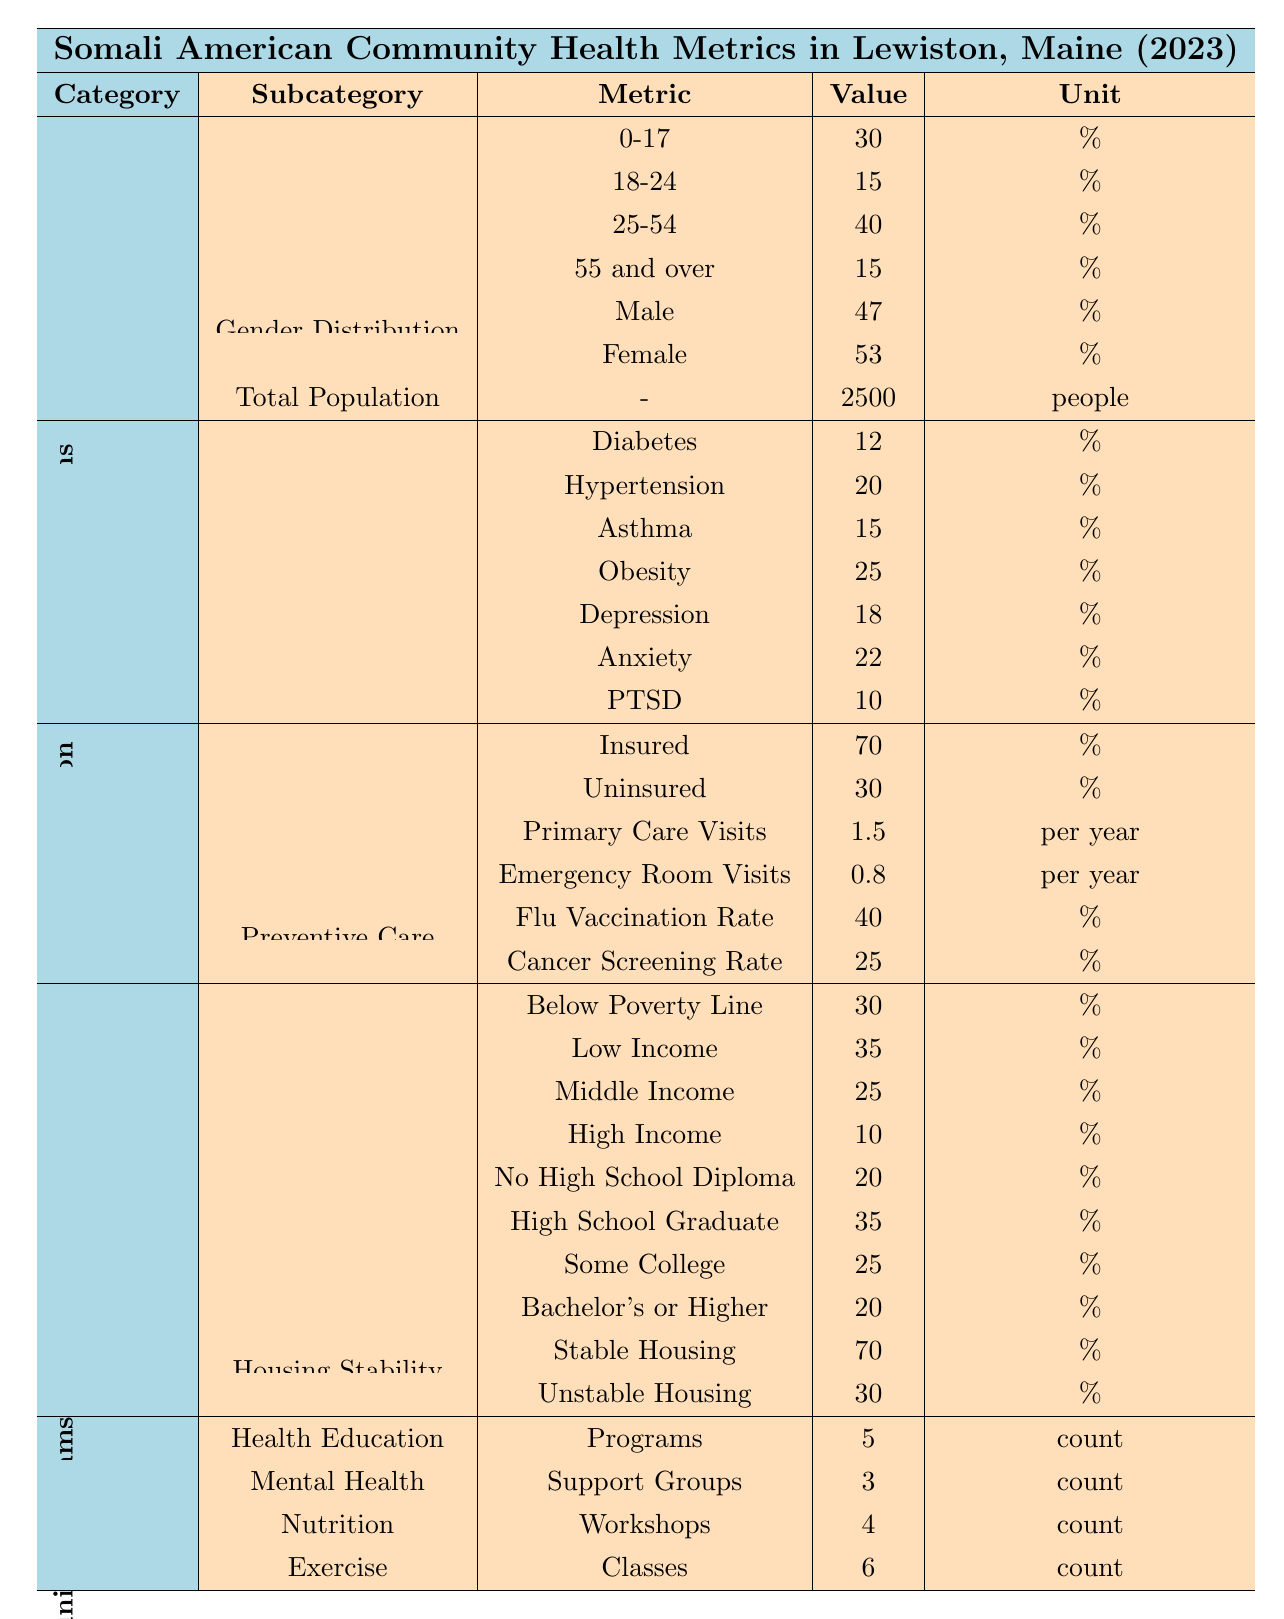What is the total population of the Somali American community in Lewiston? The total population figure is listed directly in the table under the 'Total Population' row, which states that it is 2500 people.
Answer: 2500 What percentage of the population is male? The male gender distribution is specifically stated in the table that 47% of the total population is male.
Answer: 47% How many Somali Americans are aged 25-54? The percentage for the age group 25-54 is given as 40%. To find the actual number, we calculate 40% of 2500, which is (0.40 * 2500) = 1000.
Answer: 1000 What is the percentage of Somali Americans insured? In the 'Access to Care' section, it states that 70% of Somali Americans are insured.
Answer: 70% Is the rate of diabetes lower than the rate of obesity in the community? The rates are provided: Diabetes at 12% and Obesity at 25%. Since 12% is less than 25%, the statement is true.
Answer: Yes What is the total percentage of the Somali American community below the poverty line and in low-income households? From the 'Income Level' row, 30% are below the poverty line and 35% are low income. Adding these together gives (30 + 35) = 65%.
Answer: 65% How many community programs focused on health education are there? The table lists that there are 5 health education programs in the community under the 'Community Programs' section.
Answer: 5 What percentage of individuals have a Bachelor's degree or higher? The education level section shows that 20% of Somali Americans have a Bachelor's or higher degree.
Answer: 20% How many emergency room visits do Somali Americans make on average per year? Under 'Access to Care', it mentions that there are 0.8 emergency room visits per year on average.
Answer: 0.8 What is the difference in percentage between the Flu vaccination rate and the Cancer screening rate? The Flu vaccination rate is 40% and the Cancer screening rate is 25%. The difference is (40 - 25) = 15%.
Answer: 15% 